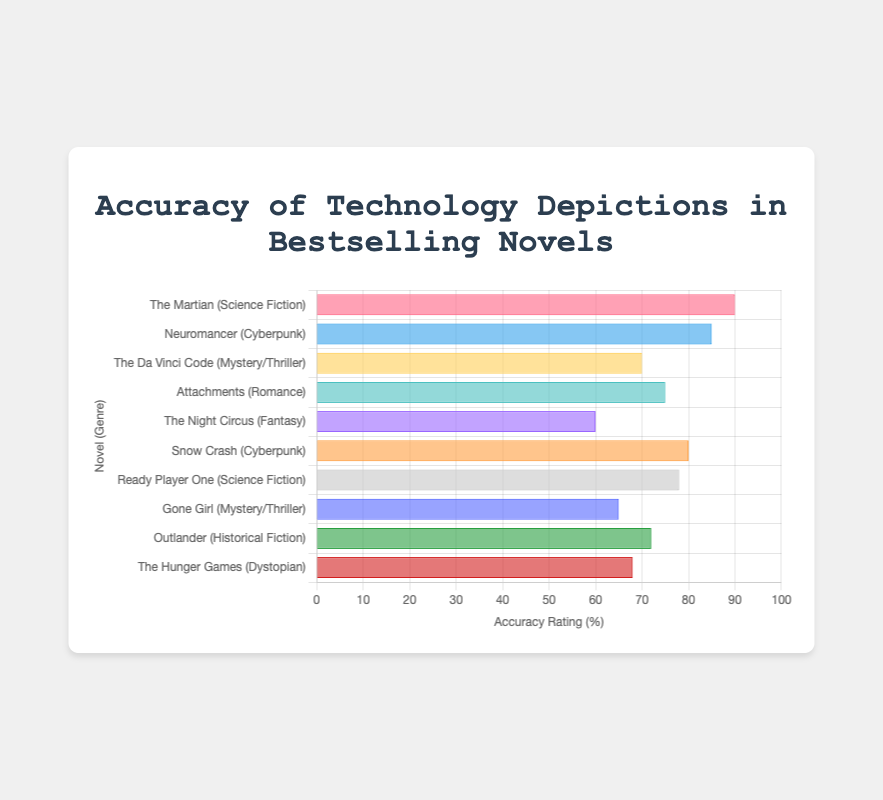What is the average accuracy rating of the Science Fiction novels? The Science Fiction novels listed are "The Martian" with an accuracy rating of 90 and "Ready Player One" with a rating of 78. The average is calculated by summing these ratings and dividing by the number of novels: (90 + 78) / 2 = 84.
Answer: 84 Which novel has the highest accuracy rating? The novel with the highest accuracy rating can be determined by looking at the bar that extends furthest to the right. "The Martian" has the highest rating of 90.
Answer: The Martian How does the accuracy rating of "Gone Girl" compare to "Outlander"? The accuracy rating of "Gone Girl" is 65, and "Outlander" is 72. To compare, "Outlander" has a higher accuracy rating than "Gone Girl" by a difference of 72 - 65 = 7.
Answer: Outlander is higher by 7 Which genre has the highest combined accuracy rating based on the novels listed? To find the genre with the highest combined accuracy, add the ratings of novels within each genre: 
- Science Fiction (90 + 78) = 168
- Cyberpunk (85 + 80) = 165
- Mystery/Thriller (70 + 65) = 135
- Romance (75) = 75
- Historical Fiction (72) = 72
- Fantasy (60) = 60
- Dystopian (68) = 68. Science Fiction has the highest combined rating of 168.
Answer: Science Fiction Identify the novel with the lowest accuracy rating. The novel with the lowest accuracy rating is represented by the shortest bar. "The Night Circus" has the lowest rating of 60.
Answer: The Night Circus What is the difference in accuracy rating between "Neuromancer" and "Snow Crash"? "Neuromancer" has an accuracy rating of 85, and "Snow Crash" has a rating of 80. The difference is calculated by subtracting the two: 85 - 80 = 5.
Answer: 5 How many novels have an accuracy rating of 75 or higher? Count the novels with ratings 75 or higher: "The Martian" (90), "Neuromancer" (85), "Attachments" (75), "Snow Crash" (80), "Ready Player One" (78). There are 5 novels in this category.
Answer: 5 What is the median accuracy rating of all listed novels? Arrange the ratings in ascending order: 60, 65, 68, 70, 72, 75, 78, 80, 85, 90. With 10 novels, the median is the average of the 5th and 6th values: (72 + 75) / 2 = 73.5.
Answer: 73.5 Which novels have accuracy ratings between 70 and 80? Novels with ratings in this range are: "The Da Vinci Code" (70), "Attachments" (75), and "Ready Player One" (78).
Answer: The Da Vinci Code, Attachments, Ready Player One What is the total accuracy rating of all novels combined? To find the total accuracy rating, sum all individual ratings: 90 + 85 + 70 + 75 + 60 + 80 + 78 + 65 + 72 + 68 = 743.
Answer: 743 